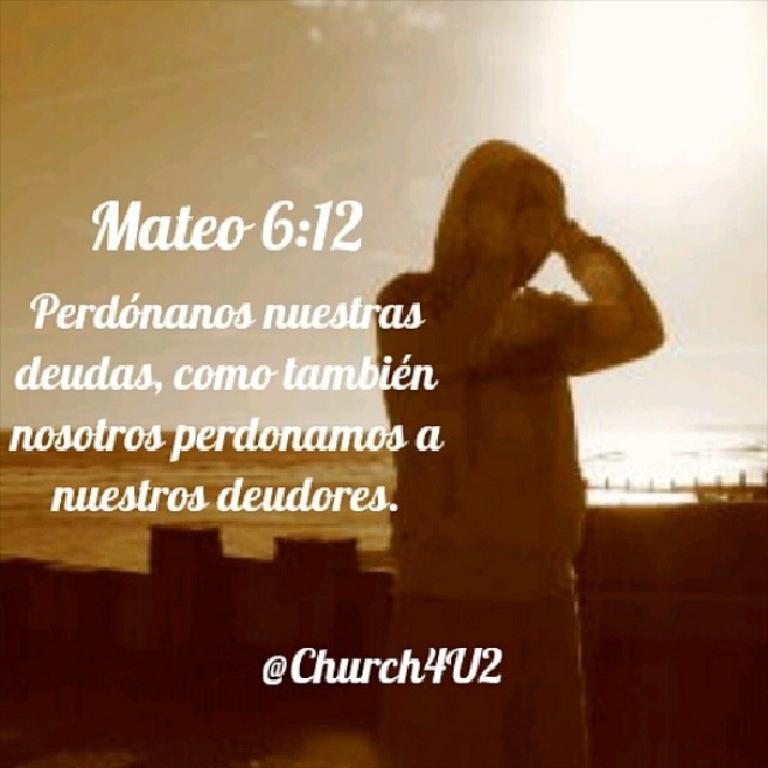Could you give a brief overview of what you see in this image? This image consists of a person and there is something written on the left side. This looks like an edited image. 